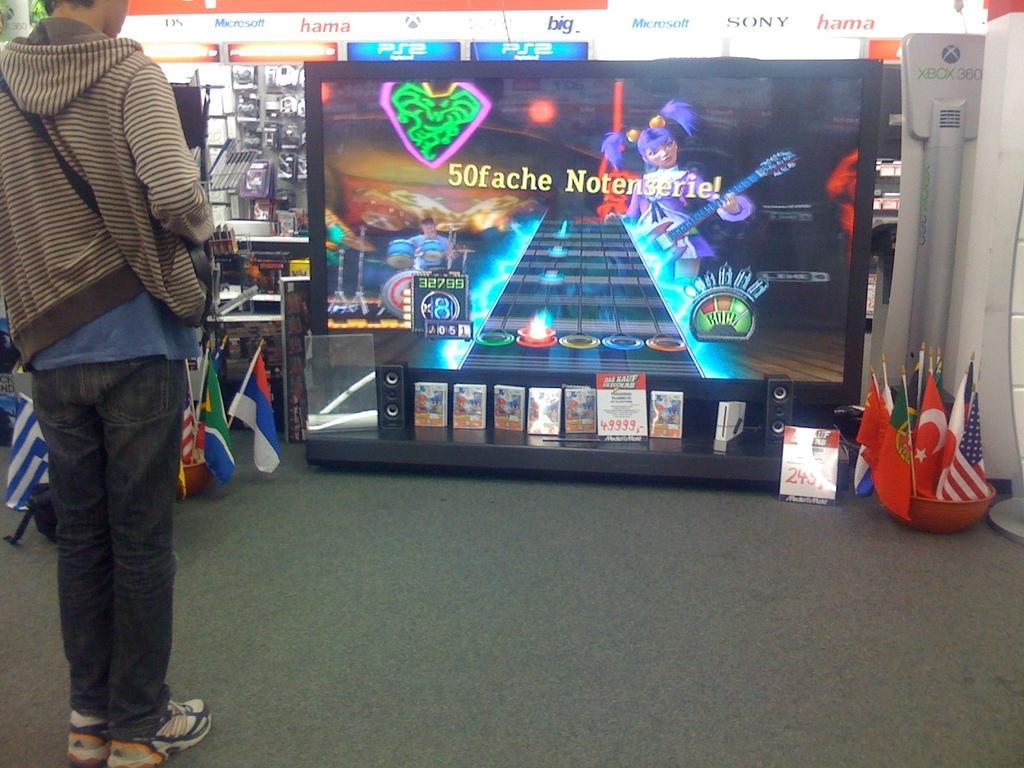Please provide a concise description of this image. in this picture we can see a person standing on the floor and here we can see flags,monitor and some objects. 